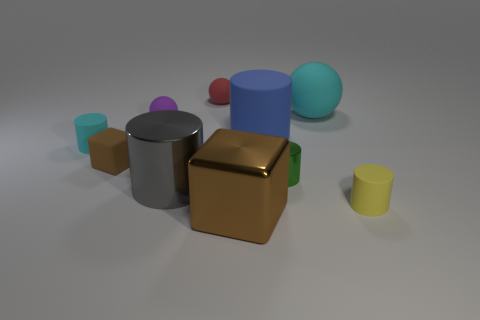There is a red object that is the same shape as the purple matte thing; what size is it?
Provide a short and direct response. Small. How many objects are big yellow matte blocks or big objects?
Your answer should be very brief. 4. There is a cyan matte object on the left side of the shiny cylinder on the right side of the small sphere that is to the right of the purple ball; how big is it?
Keep it short and to the point. Small. What number of big matte cylinders are the same color as the small shiny object?
Give a very brief answer. 0. What number of large cubes have the same material as the small purple sphere?
Keep it short and to the point. 0. What number of things are tiny green cylinders or rubber things on the right side of the green metal thing?
Provide a short and direct response. 3. There is a metal thing in front of the rubber cylinder in front of the tiny rubber cylinder that is to the left of the purple rubber ball; what color is it?
Keep it short and to the point. Brown. What is the size of the brown thing behind the small yellow rubber cylinder?
Offer a very short reply. Small. How many large objects are brown matte blocks or balls?
Ensure brevity in your answer.  1. What is the color of the big thing that is both to the right of the tiny red object and in front of the tiny rubber cube?
Your answer should be compact. Brown. 